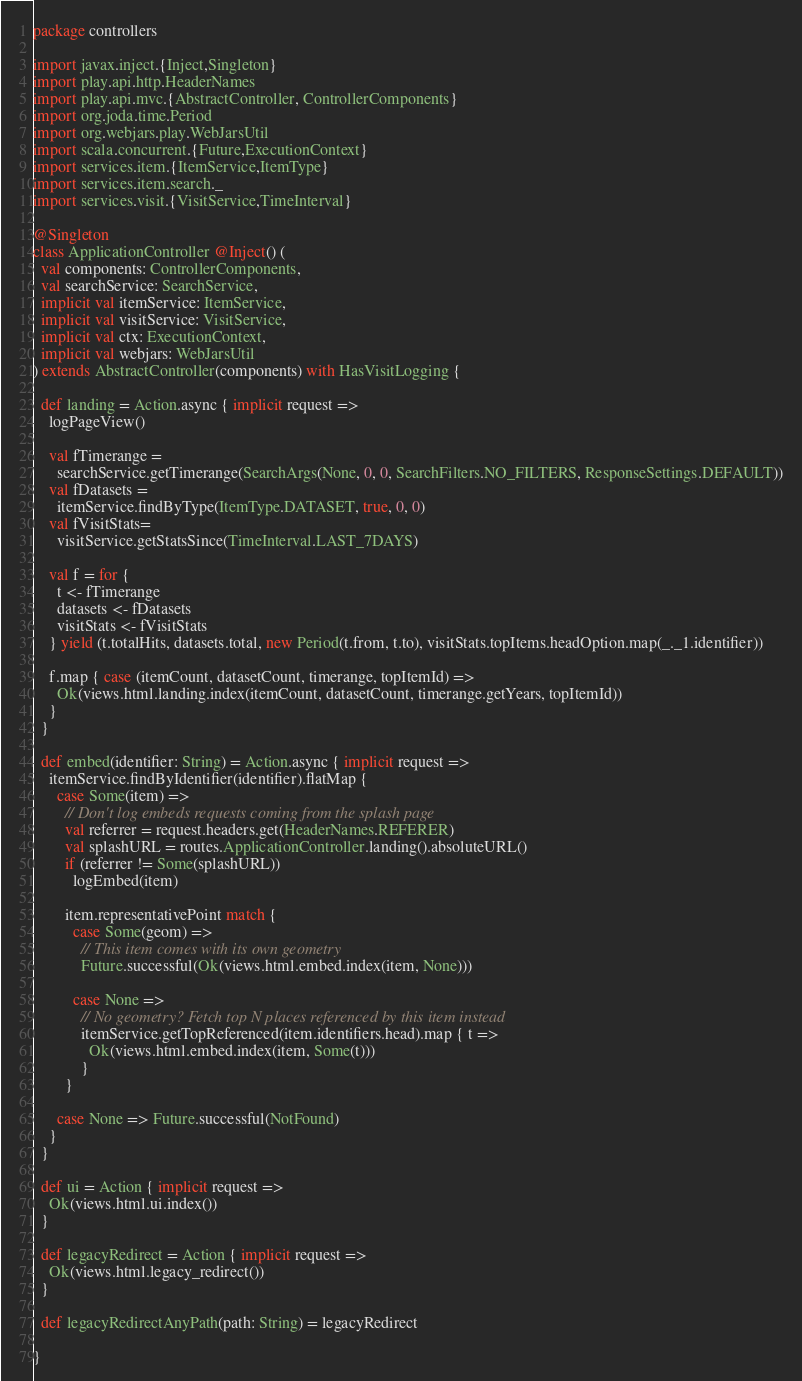Convert code to text. <code><loc_0><loc_0><loc_500><loc_500><_Scala_>package controllers

import javax.inject.{Inject,Singleton}
import play.api.http.HeaderNames
import play.api.mvc.{AbstractController, ControllerComponents}
import org.joda.time.Period
import org.webjars.play.WebJarsUtil
import scala.concurrent.{Future,ExecutionContext}
import services.item.{ItemService,ItemType}
import services.item.search._
import services.visit.{VisitService,TimeInterval}

@Singleton
class ApplicationController @Inject() (
  val components: ControllerComponents,
  val searchService: SearchService,
  implicit val itemService: ItemService,
  implicit val visitService: VisitService,
  implicit val ctx: ExecutionContext,
  implicit val webjars: WebJarsUtil
) extends AbstractController(components) with HasVisitLogging {

  def landing = Action.async { implicit request =>
    logPageView()

    val fTimerange =
      searchService.getTimerange(SearchArgs(None, 0, 0, SearchFilters.NO_FILTERS, ResponseSettings.DEFAULT))
    val fDatasets =
      itemService.findByType(ItemType.DATASET, true, 0, 0)
    val fVisitStats=
      visitService.getStatsSince(TimeInterval.LAST_7DAYS)

    val f = for {
      t <- fTimerange
      datasets <- fDatasets
      visitStats <- fVisitStats
    } yield (t.totalHits, datasets.total, new Period(t.from, t.to), visitStats.topItems.headOption.map(_._1.identifier))

    f.map { case (itemCount, datasetCount, timerange, topItemId) =>
      Ok(views.html.landing.index(itemCount, datasetCount, timerange.getYears, topItemId))
    }
  }

  def embed(identifier: String) = Action.async { implicit request =>
    itemService.findByIdentifier(identifier).flatMap {
      case Some(item) =>
        // Don't log embeds requests coming from the splash page
        val referrer = request.headers.get(HeaderNames.REFERER)
        val splashURL = routes.ApplicationController.landing().absoluteURL()
        if (referrer != Some(splashURL))
          logEmbed(item)

        item.representativePoint match {
          case Some(geom) =>
            // This item comes with its own geometry
            Future.successful(Ok(views.html.embed.index(item, None)))

          case None =>
            // No geometry? Fetch top N places referenced by this item instead
            itemService.getTopReferenced(item.identifiers.head).map { t =>
              Ok(views.html.embed.index(item, Some(t)))
            }
        }

      case None => Future.successful(NotFound)
    }
  }

  def ui = Action { implicit request =>
    Ok(views.html.ui.index())
  }

  def legacyRedirect = Action { implicit request =>
    Ok(views.html.legacy_redirect())
  }

  def legacyRedirectAnyPath(path: String) = legacyRedirect

}
</code> 